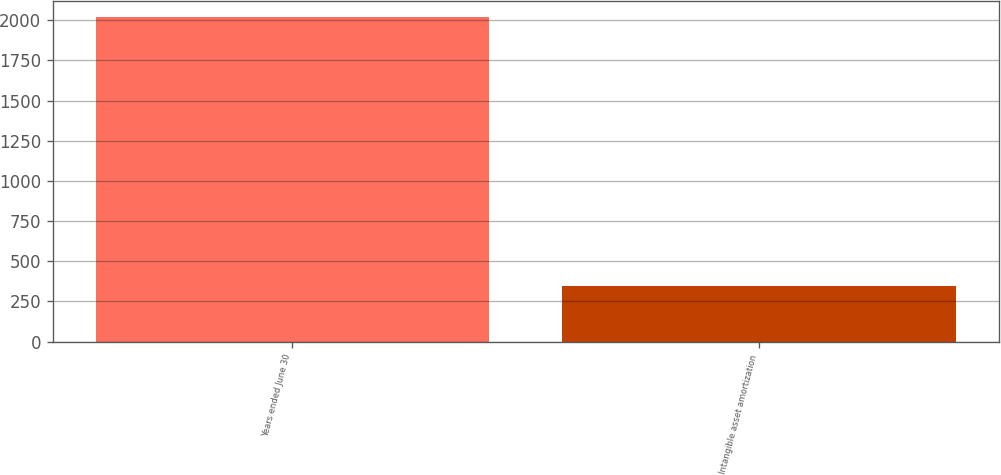<chart> <loc_0><loc_0><loc_500><loc_500><bar_chart><fcel>Years ended June 30<fcel>Intangible asset amortization<nl><fcel>2019<fcel>349<nl></chart> 